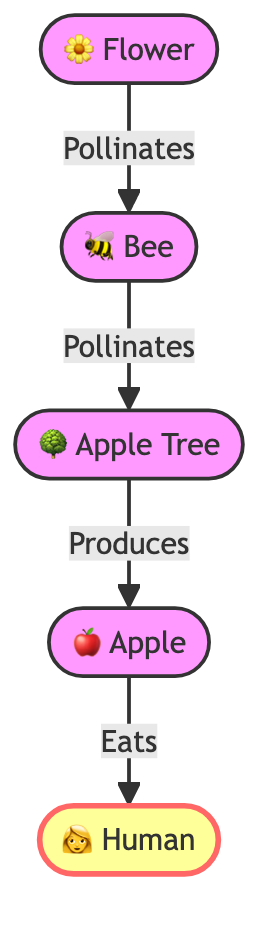What is the first element in the food chain? The first element in the food chain is the "Flower," as indicated at the top of the diagram, which serves as the starting point for the flow of energy in the food chain.
Answer: Flower How many nodes are in the food chain? The diagram contains five distinct nodes: Flower, Bee, Apple Tree, Apple, and Human. Counting these gives a total of five nodes in the food chain.
Answer: 5 What does the bee do in the food chain? The bee is shown to be involved in the pollination process, specifically pollinating the flower as well as the apple tree, thus playing a crucial role in plant reproduction.
Answer: Pollinates Which element produces the apple? The "Apple Tree" is specified as the element that produces the apple in the food chain, demonstrating the relationship between apple trees and the fruit they create.
Answer: Apple Tree Who eats the apple? According to the diagram, the "Human" is the entity that eats the apple, indicating the flow of energy from the apple to the human.
Answer: Human How many pollination steps are there in the food chain? There are two steps of pollination in the food chain: the first is from the flower to the bee, and the second is from the bee to the apple tree. This total gives us two distinct steps involving pollination.
Answer: 2 What is the last element in the food chain? The last element in the food chain is the "Human," which is depicted at the bottom of the diagram, representing the end consumer in this ecosystem.
Answer: Human What do humans rely on in the food chain? Humans rely on "Apples," as shown in the diagram where the relationship indicates that humans consume apples derived from the apple trees, linking humans directly to the fruit.
Answer: Apples 